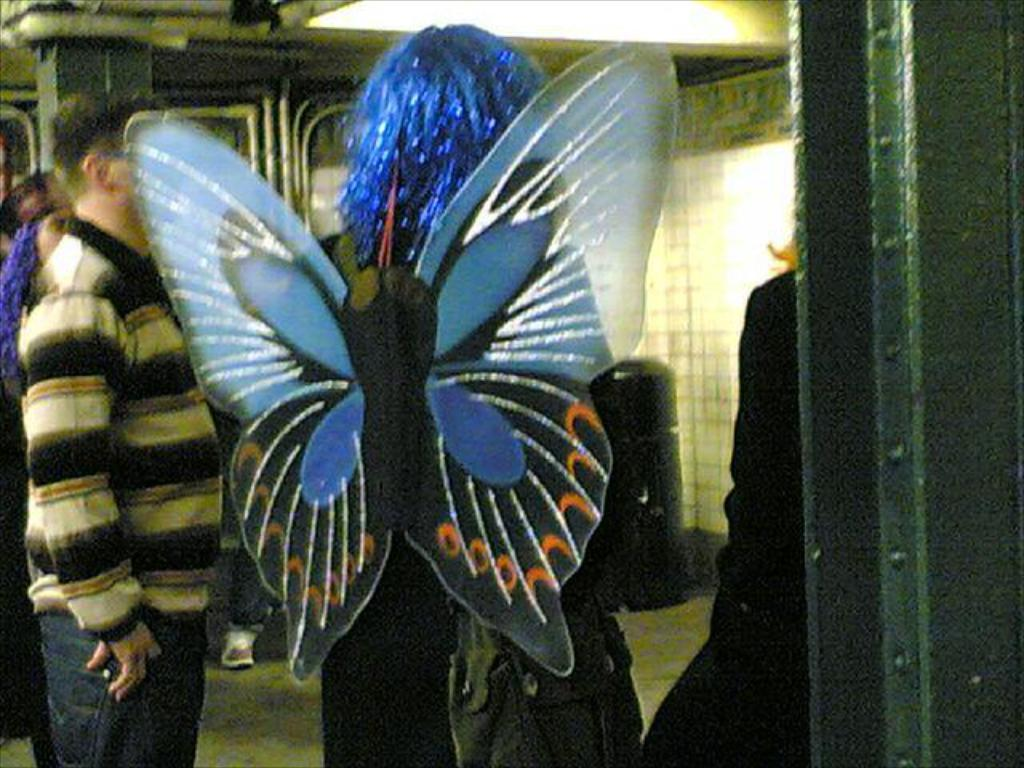Who is the main subject in the image? There is a person in the center of the image. What is the person wearing on their body? The person is wearing a bag. Can you describe the person's attire in more detail? The person is wearing a fancy costume. Are there any other people in the image? Yes, there are people standing in the image. What structures can be seen in the background? There is a wall and a pillar in the image. What type of jeans are the cows wearing in the image? There are no cows present in the image, and therefore no jeans or any other clothing items can be attributed to them. 